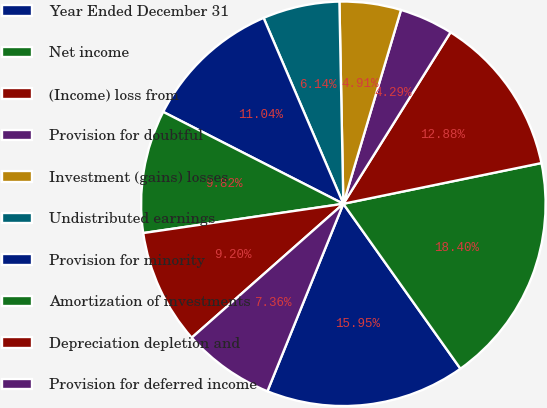<chart> <loc_0><loc_0><loc_500><loc_500><pie_chart><fcel>Year Ended December 31<fcel>Net income<fcel>(Income) loss from<fcel>Provision for doubtful<fcel>Investment (gains) losses<fcel>Undistributed earnings<fcel>Provision for minority<fcel>Amortization of investments<fcel>Depreciation depletion and<fcel>Provision for deferred income<nl><fcel>15.95%<fcel>18.4%<fcel>12.88%<fcel>4.29%<fcel>4.91%<fcel>6.14%<fcel>11.04%<fcel>9.82%<fcel>9.2%<fcel>7.36%<nl></chart> 